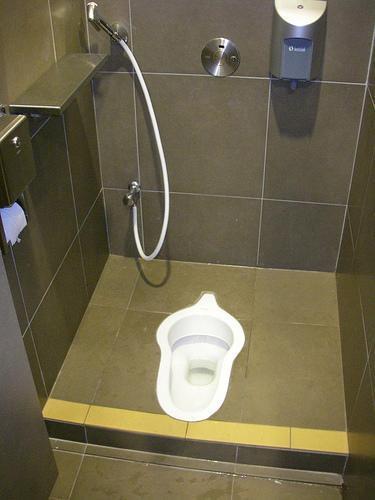How many steps are in the picture?
Give a very brief answer. 1. 